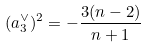<formula> <loc_0><loc_0><loc_500><loc_500>( a _ { 3 } ^ { \vee } ) ^ { 2 } = - \frac { 3 ( n - 2 ) } { n + 1 }</formula> 